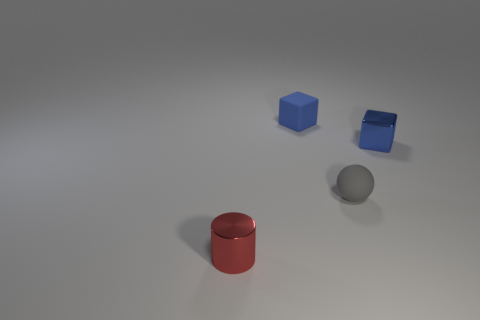How many blue blocks must be subtracted to get 1 blue blocks? 1 Add 3 red cylinders. How many objects exist? 7 Subtract all purple cubes. Subtract all brown balls. How many cubes are left? 2 Subtract all red rubber things. Subtract all blue blocks. How many objects are left? 2 Add 3 tiny metal objects. How many tiny metal objects are left? 5 Add 1 metallic cubes. How many metallic cubes exist? 2 Subtract 0 green balls. How many objects are left? 4 Subtract all cylinders. How many objects are left? 3 